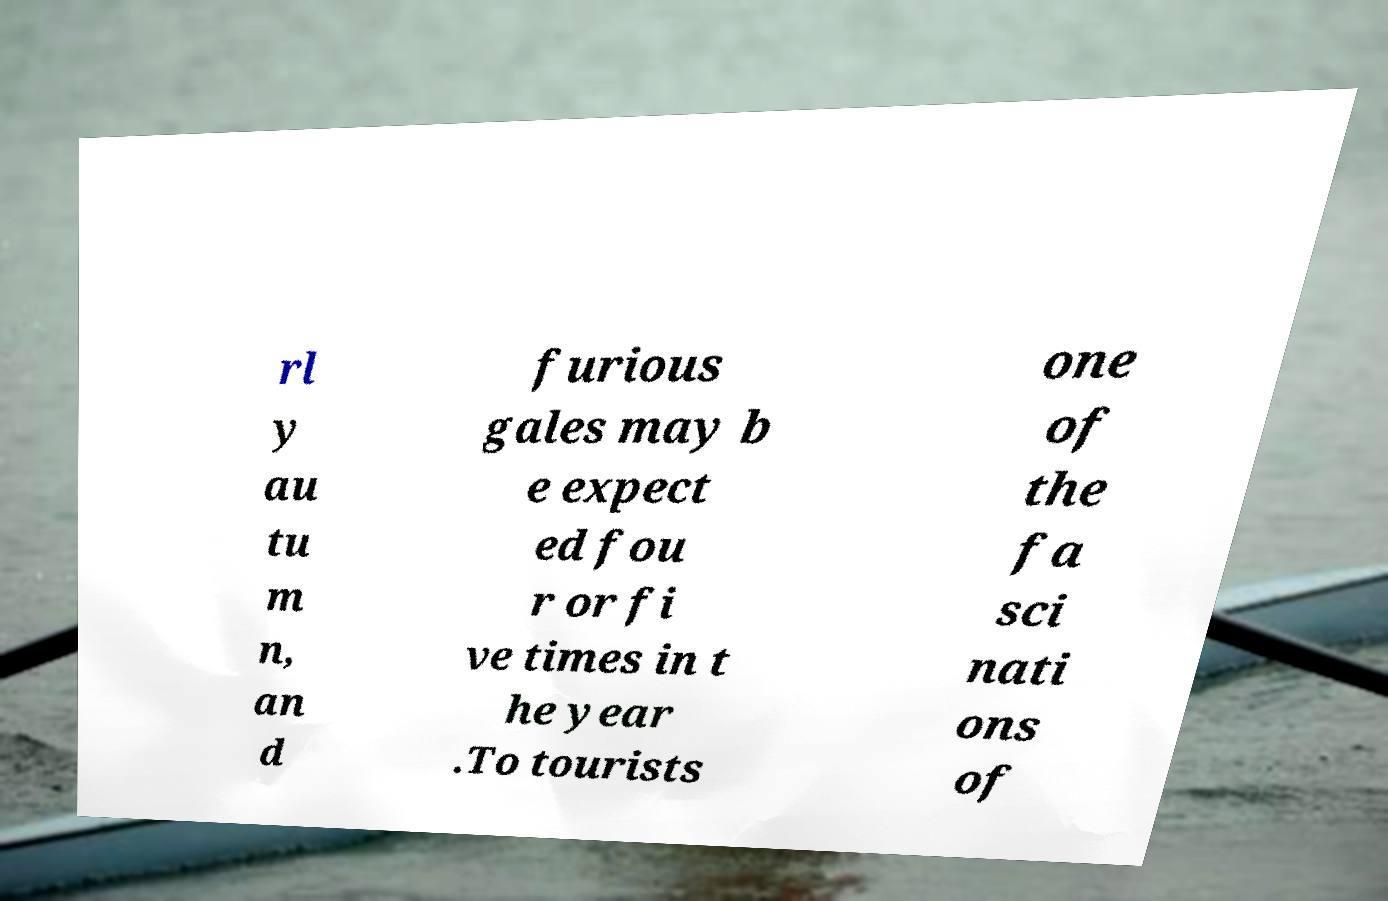Could you extract and type out the text from this image? rl y au tu m n, an d furious gales may b e expect ed fou r or fi ve times in t he year .To tourists one of the fa sci nati ons of 